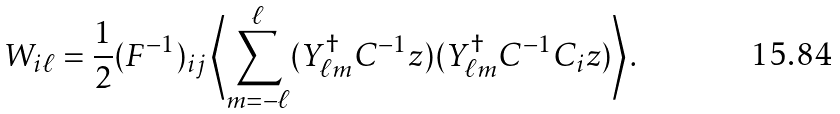Convert formula to latex. <formula><loc_0><loc_0><loc_500><loc_500>W _ { i \ell } = \frac { 1 } { 2 } ( F ^ { - 1 } ) _ { i j } \left \langle \sum _ { m = - \ell } ^ { \ell } ( { Y } _ { \ell m } ^ { \dagger } { C } ^ { - 1 } { z } ) ( { Y } _ { \ell m } ^ { \dagger } { C } ^ { - 1 } { C } _ { i } { z } ) \right \rangle .</formula> 